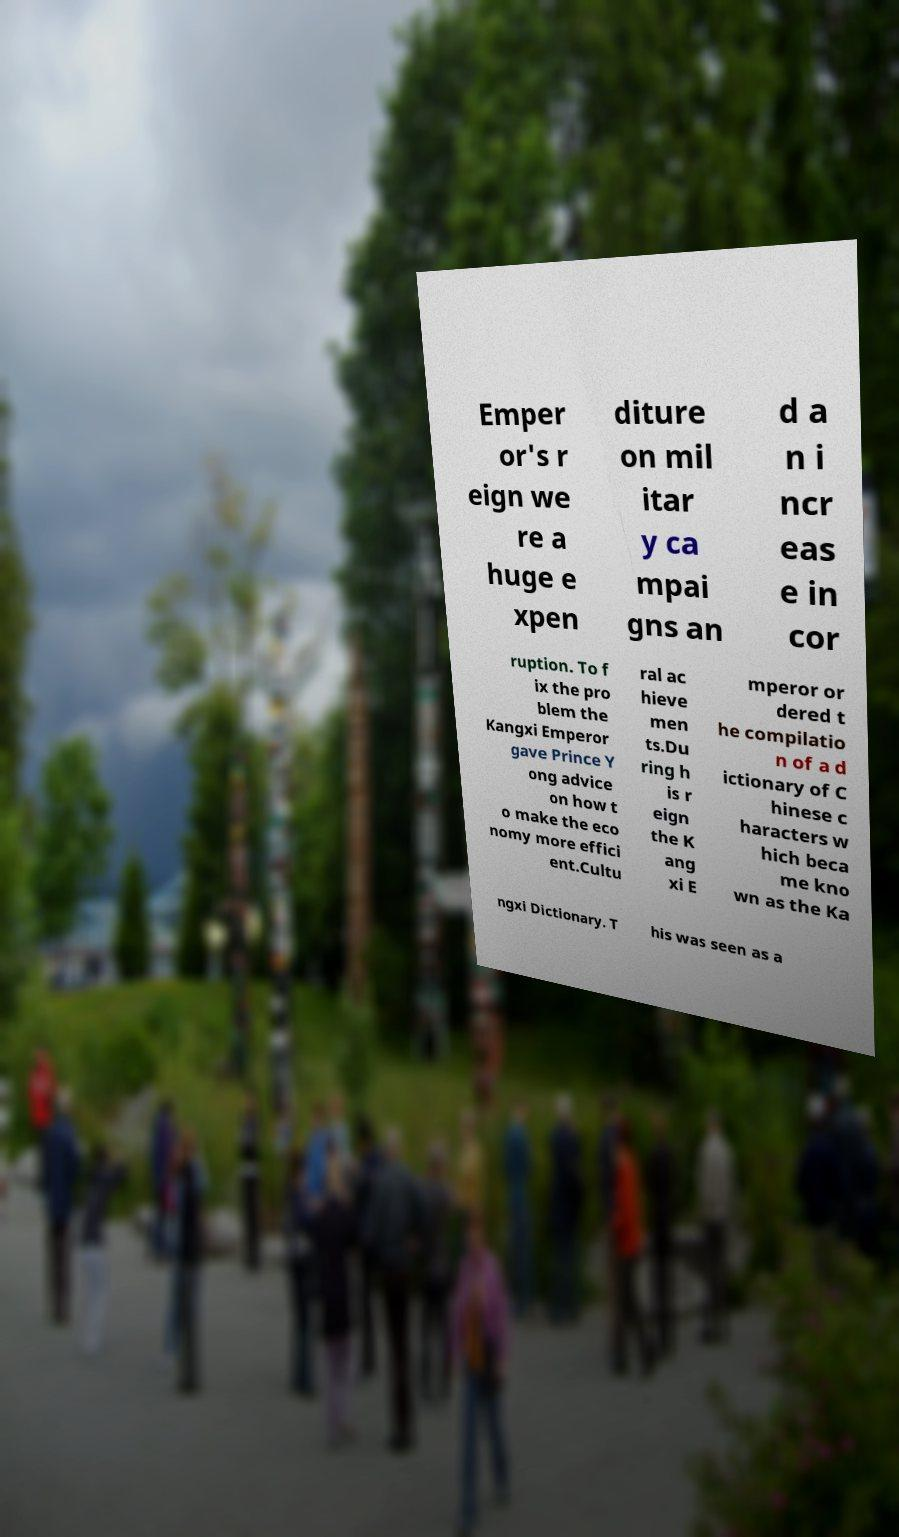Can you accurately transcribe the text from the provided image for me? Emper or's r eign we re a huge e xpen diture on mil itar y ca mpai gns an d a n i ncr eas e in cor ruption. To f ix the pro blem the Kangxi Emperor gave Prince Y ong advice on how t o make the eco nomy more effici ent.Cultu ral ac hieve men ts.Du ring h is r eign the K ang xi E mperor or dered t he compilatio n of a d ictionary of C hinese c haracters w hich beca me kno wn as the Ka ngxi Dictionary. T his was seen as a 